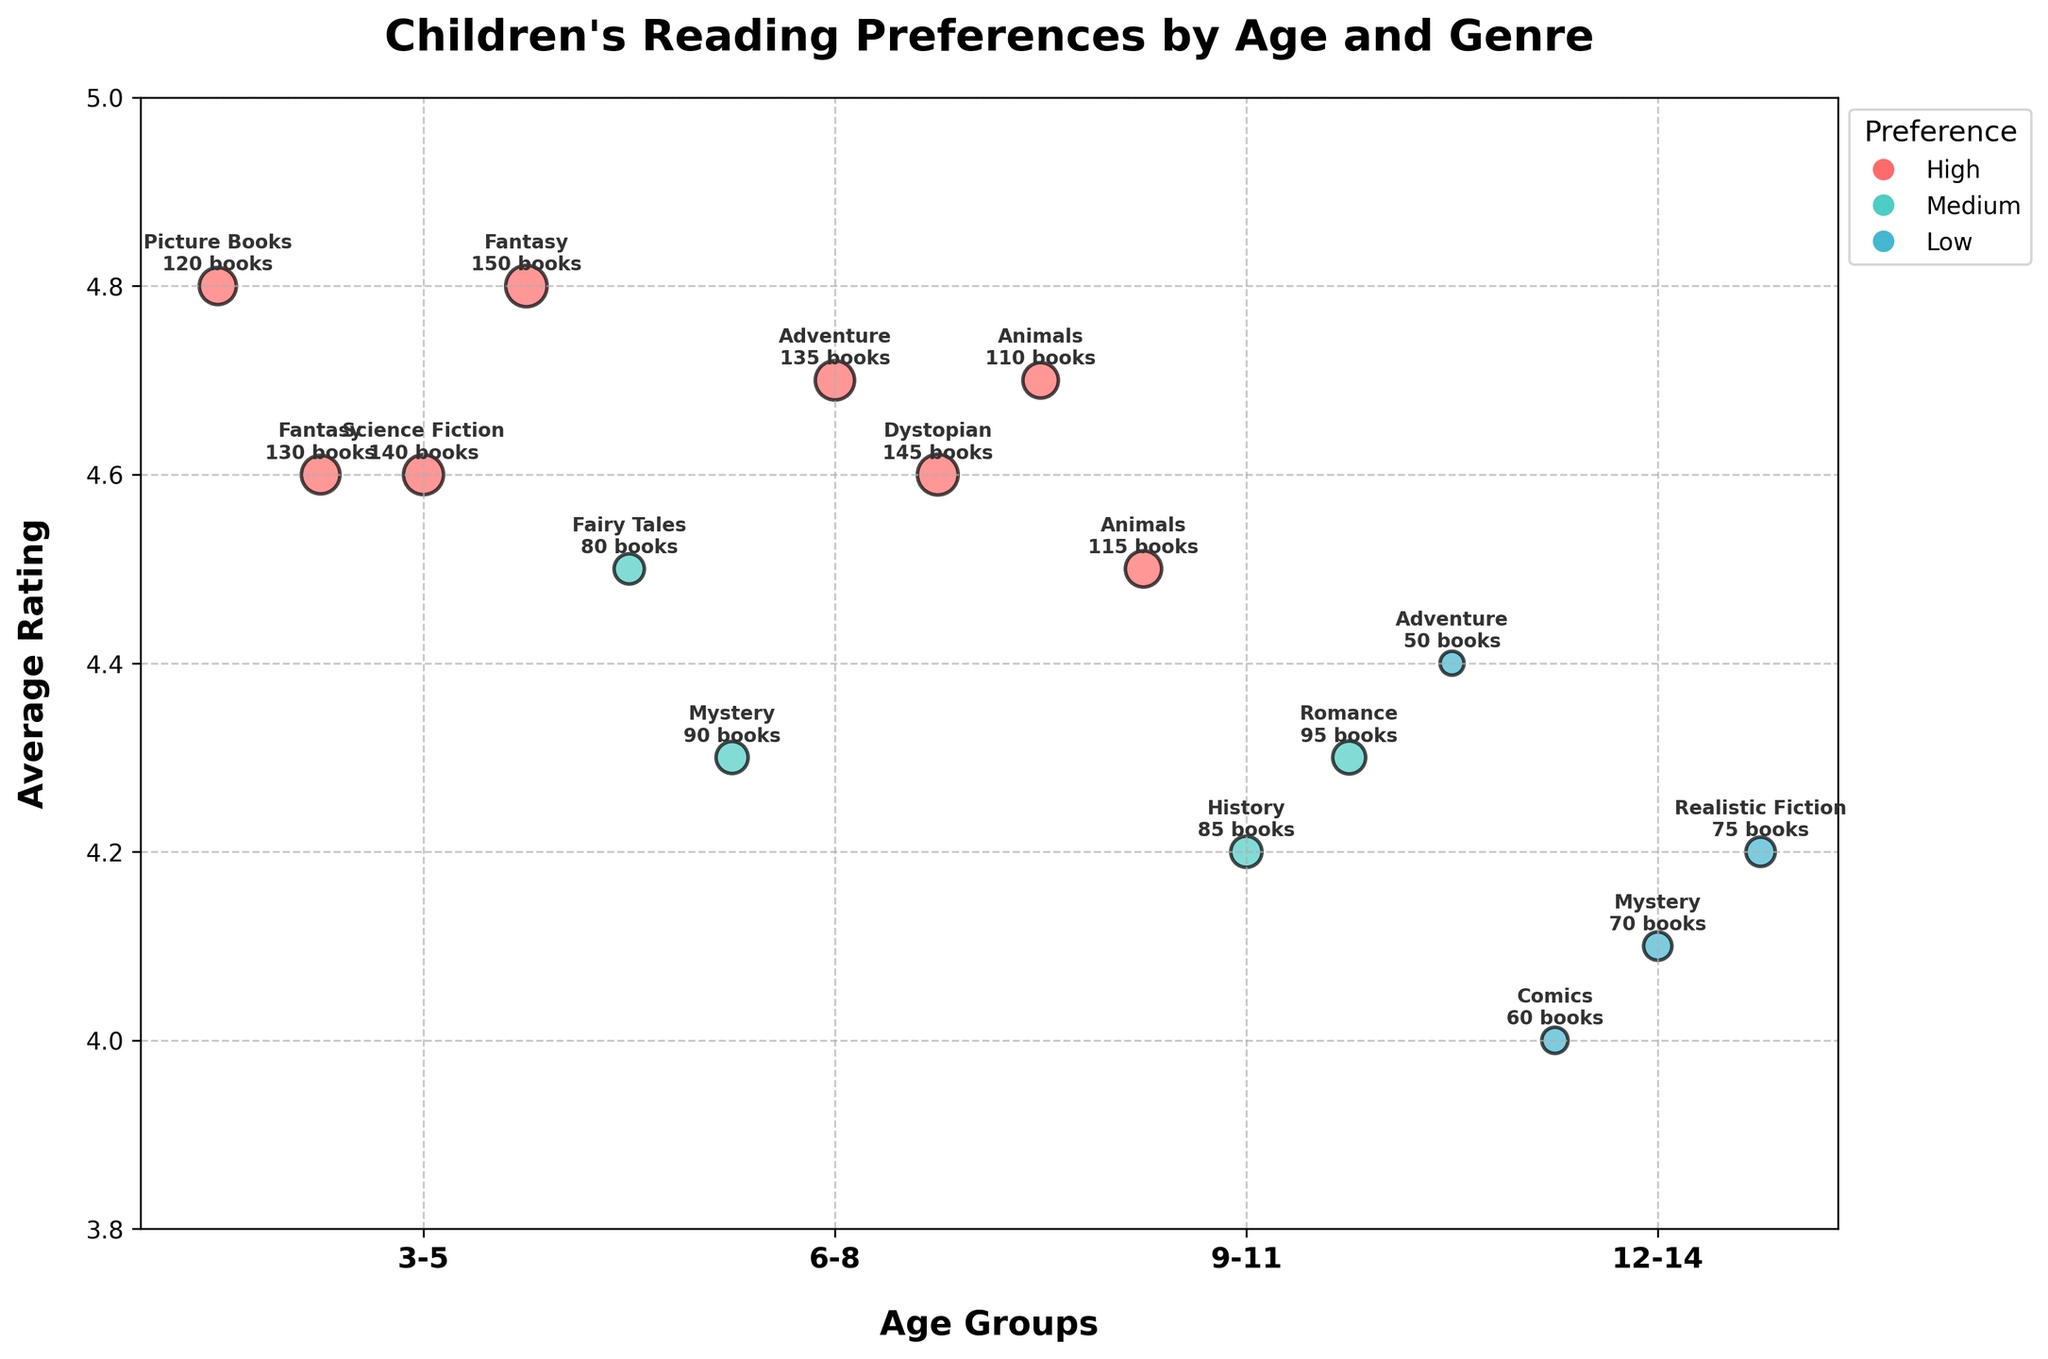What is the title of the figure? The title is usually placed at the top of the figure. In this case, it reads "Children's Reading Preferences by Age and Genre".
Answer: Children's Reading Preferences by Age and Genre For which age group is Fantasy the highest rated genre? Find the bubbles annotated with "Fantasy" and check their positions on the y-axis. The highest Fantasy rating is associated with the age group 12-14.
Answer: 12-14 Which age group has the lowest-rated book genre? Compare the y-axis positions of all the bubbles and identify the one lowest on the scale, which signifies the lowest average rating. The lowest rating goes to the Comics genre for age group 6-8.
Answer: 6-8 How many genres have a 'High' preference for the age group 9-11? Look at the colors of the bubbles for the 9-11 age group. Count the red (High preference) bubbles. The Adventure and Science Fiction genres have a 'High' preference, totaling 2.
Answer: 2 Which genre has the most books in the age group 3-5? Check the size of the bubbles within the 3-5 age group. The largest bubble signifies the genre with the most books. This is Picture Books with 120 books.
Answer: Picture Books What is the average rating of all genres with 'Medium' preference in the figure? Find all bubbles marked with 'Medium' preference (colored light blue). Average their y-axis values: (4.5 [Fairy Tales] + 4.3 [Mystery] + 4.2 [History] + 4.3 [Romance]) / 4 = 4.325
Answer: 4.325 Which two genres for the 12-14 age group have a 'High' preference? Identify the bubbles in the 12-14 age group by color. The two bubbles maintaining a red color (High preference) are Fantasy and Dystopian.
Answer: Fantasy and Dystopian Compare the average book rating of the age groups 6-8 and 9-11. Which has a higher rating? Calculate the average rating for each age group. 
6-8: (4.6 [Fantasy] + 4.3 [Mystery] + 4.5 [Animals] + 4.0 [Comics]) / 4 = 4.35
9-11: (4.6 [Science Fiction] + 4.7 [Adventure] + 4.2 [History] + 4.1 [Mystery]) / 4 = 4.4
9-11 age group has a higher average rating.
Answer: 9-11 What genre has the lowest preference for all age groups? Examine the colors of the bubbles for each age group. Identify the genre(s) marked with the blue color (Low preference). Adventure (3-5), Comics (6-8), Mystery (9-11), and Realistic Fiction (12-14) are the Low preference genres.
Answer: Various genres in each age group What is the highest-rated book genre for the age group 6-8? Check the y-axis positions of all the bubbles corresponding to the 6-8 age group. The highest point on the y-axis is for Fantasy with an average rating of 4.6.
Answer: Fantasy 